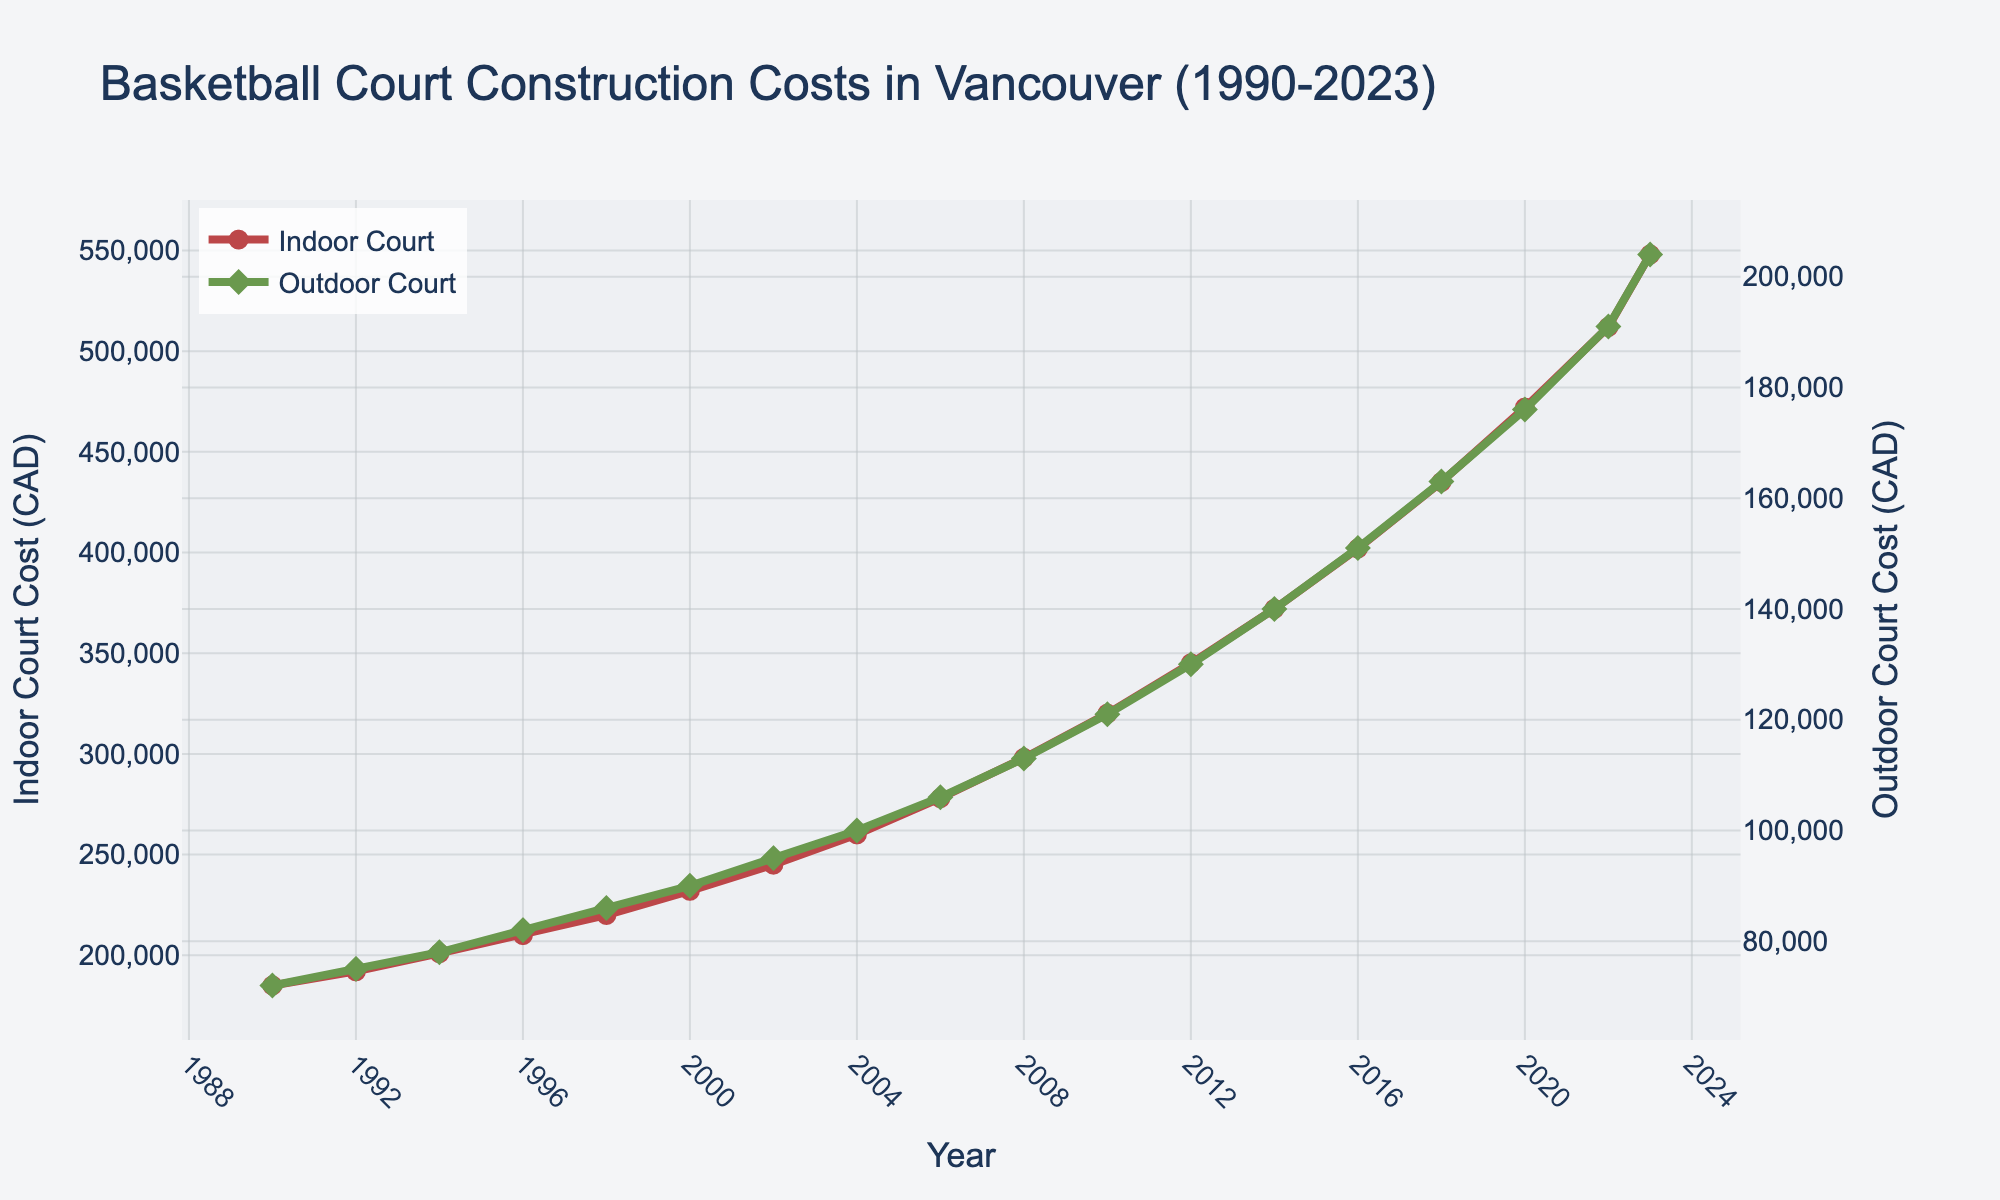what is the average cost of constructing an indoor court from 1990 to 2000? First, sum the indoor court costs for the years 1990, 1992, 1994, 1996, 1998, and 2000: (185000 + 192000 + 201000 + 210000 + 220000 + 232000) = 1240000. Then, divide this sum by the number of years (6): 1240000 / 6 = 206666.67
Answer: 206666.67 In 2023, how much more expensive is it to build an indoor court compared to an outdoor court? In 2023, the indoor court cost is 548000 CAD and the outdoor court cost is 204000 CAD. Subtract the outdoor cost from the indoor cost: 548000 - 204000 = 344000.
Answer: 344000 Has the cost of constructing outdoor courts increased more rapidly than indoor courts from 1990 to 2023? To determine the rate of increase, compare the percentage increase for both types of courts. Indoor court cost in 1990: 185000 CAD, in 2023: 548000 CAD. Percentage increase: (548000 - 185000) / 185000 * 100 ≈ 196.22%. Outdoor court cost in 1990: 72000 CAD, in 2023: 204000 CAD. Percentage increase: (204000 - 72000) / 72000 * 100 ≈ 183.33%. Thus, indoor court costs have increased more rapidly.
Answer: No How much did the cost of building outdoor courts increase each year from 2000 to 2010? First, find the outdoor court costs for 2000 and 2010: 90000 CAD and 121000 CAD. Calculate the total increase: 121000 - 90000 = 31000 CAD. Then divide this by the number of years (10): 31000 / 10 = 3100.
Answer: 3100 During which period (1990-2000 or 2000-2010) did the cost of constructing an indoor court increase more? Calculate the increase from 1990 to 2000: 232000 - 185000 = 47000. From 2000 to 2010: 320000 - 232000 = 88000. The cost increase was greater from 2000 to 2010.
Answer: 2000-2010 Which year had the highest difference in cost between indoor and outdoor courts? Subtract the outdoor court cost from the indoor court cost for each year, then find the highest difference. 2023 has the highest difference: 548000 - 204000 = 344000.
Answer: 2023 By what percentage has the cost of an indoor court increased from 2012 to 2022? Indoor court cost in 2012: 345000 CAD, in 2022: 512000 CAD. Calculate the percentage increase: (512000 - 345000) / 345000 * 100 ≈ 48.41%.
Answer: 48.41% What is the difference in the average cost per year for indoor courts between 2010 and 2020? Calculate the average cost for indoor courts for 2010 and 2020. 2010: 320000 CAD, 2020: 472000 CAD. Average cost for each year: 320000 and 472000 respectively. Difference: 472000 - 320000 = 152000.
Answer: 152000 